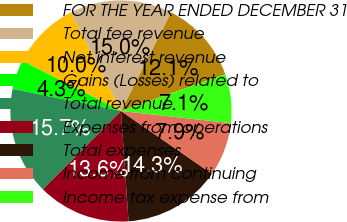Convert chart. <chart><loc_0><loc_0><loc_500><loc_500><pie_chart><fcel>FOR THE YEAR ENDED DECEMBER 31<fcel>Total fee revenue<fcel>Net interest revenue<fcel>Gains (Losses) related to<fcel>Total revenue<fcel>Expenses from operations<fcel>Total expenses<fcel>Income from continuing<fcel>Income tax expense from<nl><fcel>12.14%<fcel>15.0%<fcel>10.0%<fcel>4.29%<fcel>15.71%<fcel>13.57%<fcel>14.29%<fcel>7.86%<fcel>7.14%<nl></chart> 